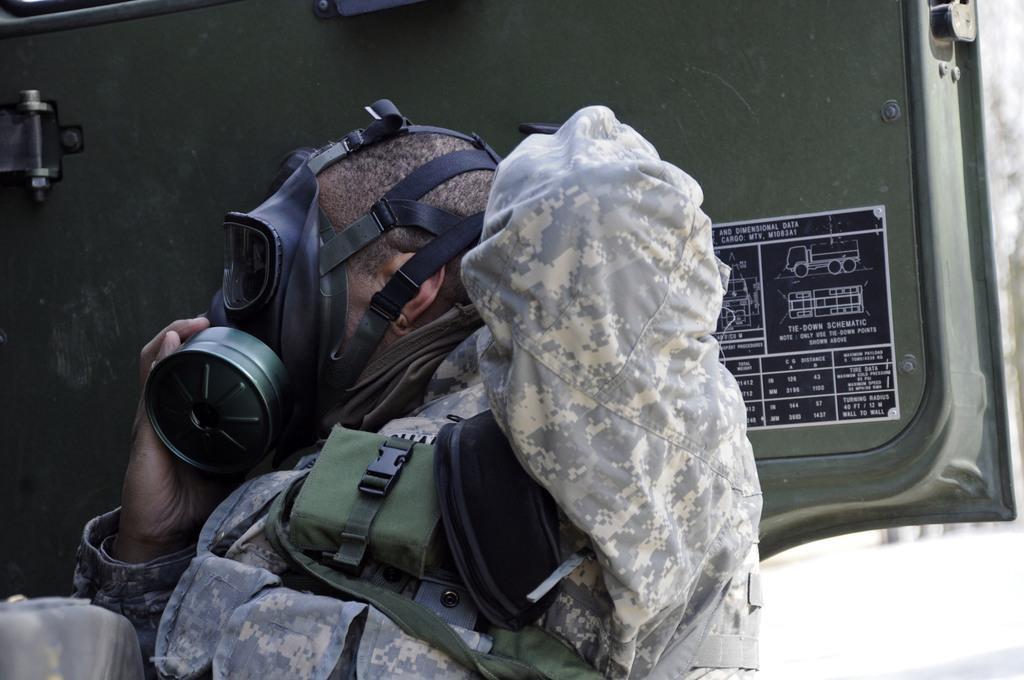Describe this image in one or two sentences. In the image there is a man with uniform and a face mask. Behind him there is a vehicle door. On the door there is a poster with images and text on it. 